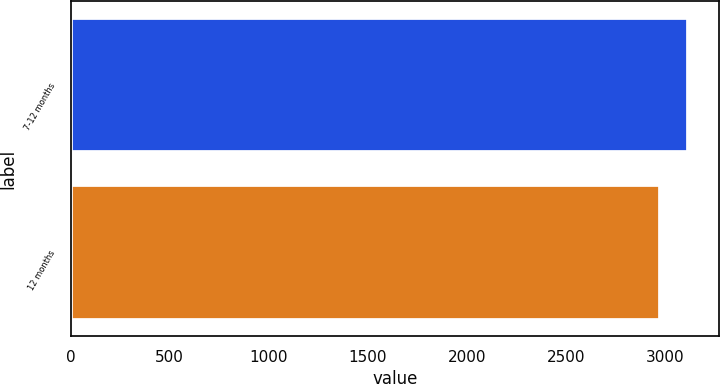Convert chart to OTSL. <chart><loc_0><loc_0><loc_500><loc_500><bar_chart><fcel>7-12 months<fcel>12 months<nl><fcel>3119<fcel>2976<nl></chart> 